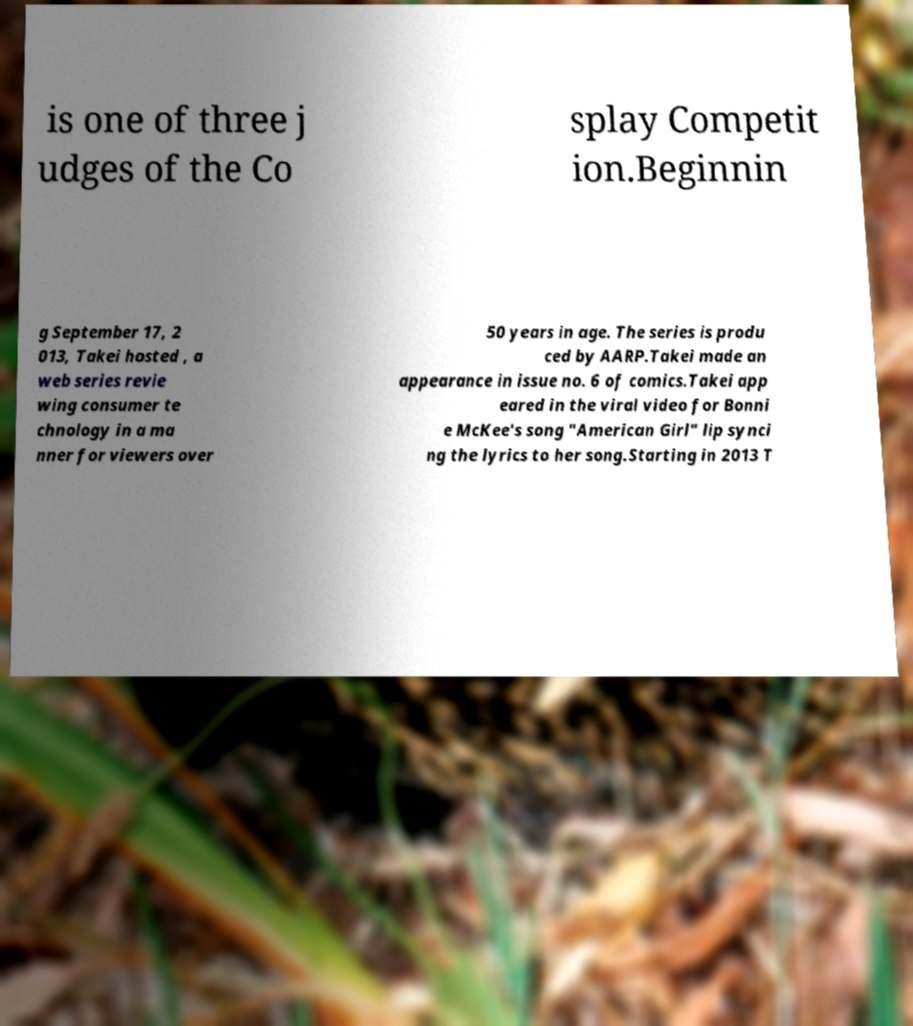Can you read and provide the text displayed in the image?This photo seems to have some interesting text. Can you extract and type it out for me? is one of three j udges of the Co splay Competit ion.Beginnin g September 17, 2 013, Takei hosted , a web series revie wing consumer te chnology in a ma nner for viewers over 50 years in age. The series is produ ced by AARP.Takei made an appearance in issue no. 6 of comics.Takei app eared in the viral video for Bonni e McKee's song "American Girl" lip synci ng the lyrics to her song.Starting in 2013 T 